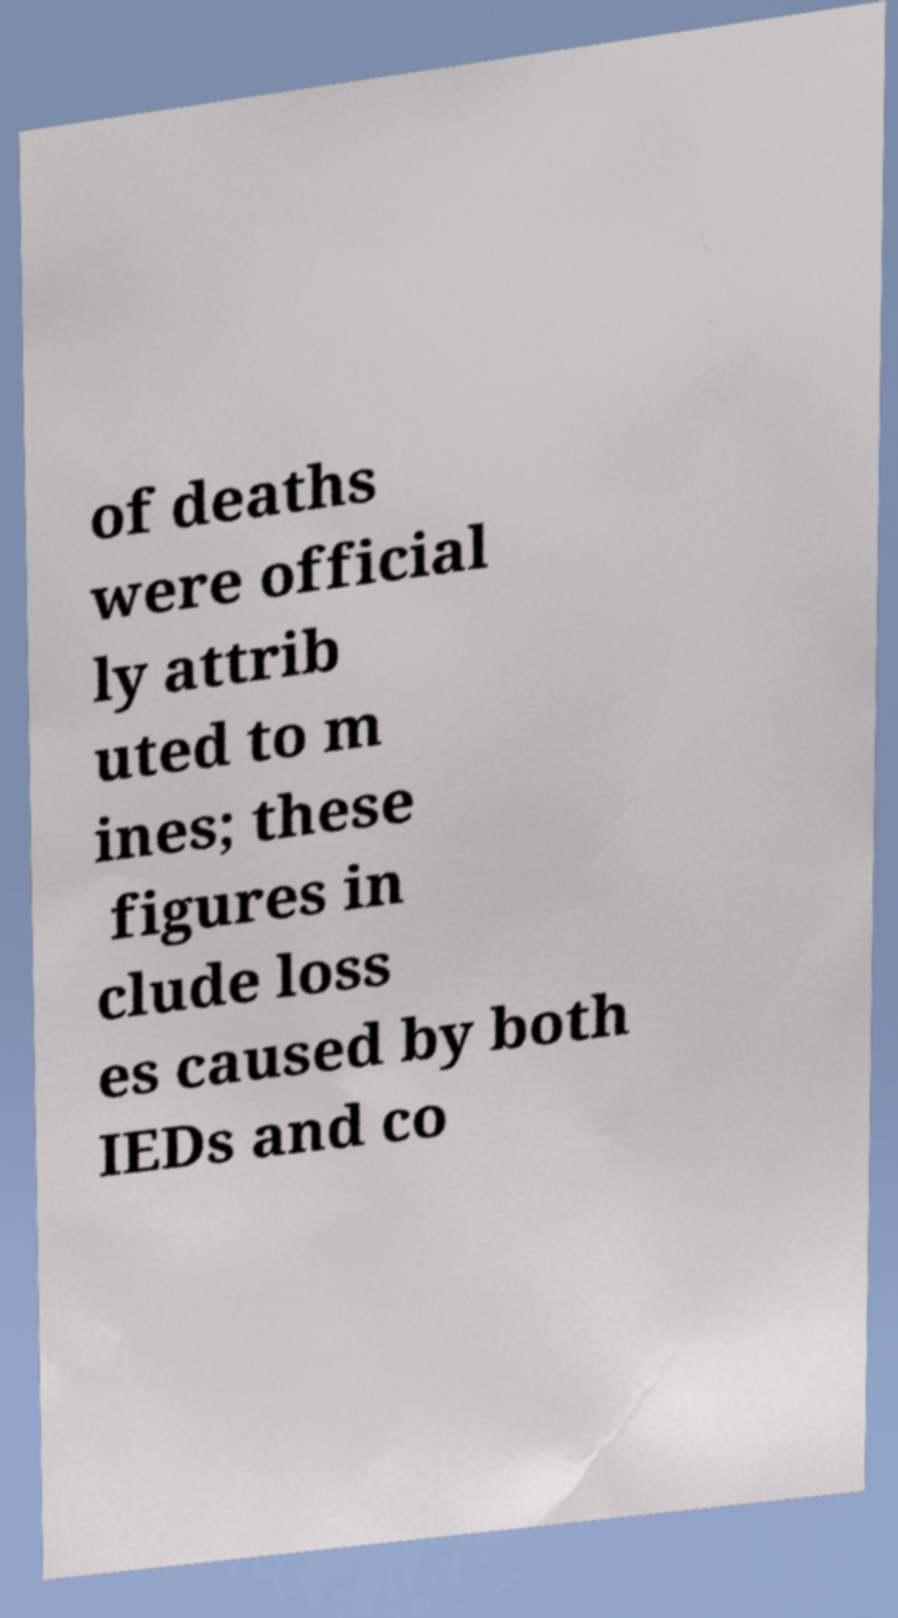Could you extract and type out the text from this image? of deaths were official ly attrib uted to m ines; these figures in clude loss es caused by both IEDs and co 